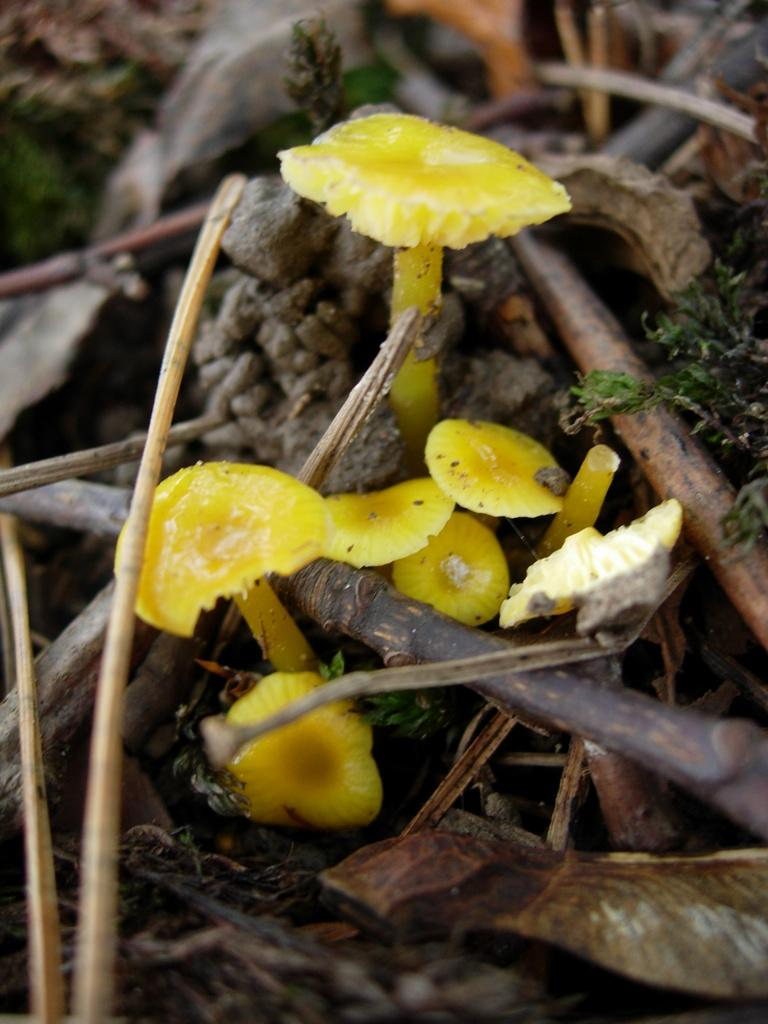What type of fungi can be seen in the image? There are mushrooms in the image. What other natural elements are present in the image? There are logs and plants in the image. What type of wrist accessory is visible on the mushroom in the image? There is no wrist accessory present on the mushroom in the image, as it is a fungus and not a living being capable of wearing accessories. 